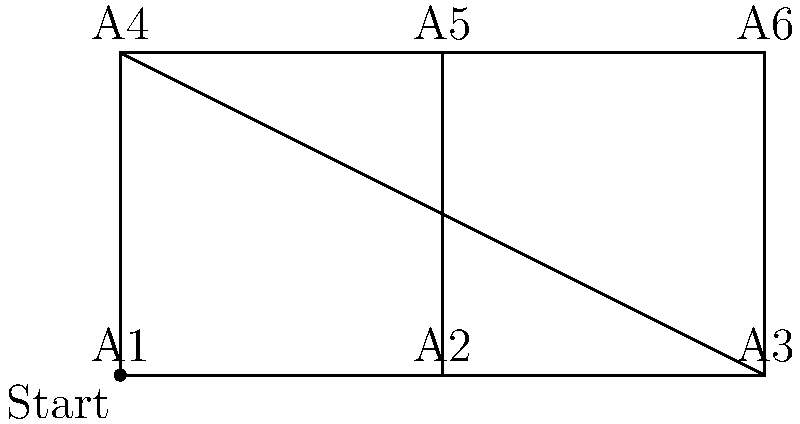As the store owner, you need to restock all aisles efficiently. The map shows 6 aisles (A1 to A6) connected by paths. Starting from A1, what's the shortest path to visit all aisles once and return to A1? To find the most efficient route, we need to consider all possible paths that visit each aisle once and return to the starting point. This is known as the Traveling Salesman Problem. For a small number of aisles like this, we can solve it by checking all possibilities:

1. There are 5! (120) possible routes, as we start and end at A1.
2. We can eliminate some routes that are clearly inefficient, such as those that cross the store multiple times.
3. The most efficient route should follow the store's layout, moving in a logical sequence.
4. Considering the layout, a good candidate for the shortest path is:
   A1 → A2 → A3 → A6 → A5 → A4 → A1

5. This path covers all aisles in a clockwise manner, following the store's layout without any backtracking.
6. The total distance of this path is 6 units (assuming each segment between adjacent aisles is 1 unit).
7. Any other path would require more movement or backtracking, resulting in a longer total distance.

Therefore, the most efficient route to restock all aisles is A1 → A2 → A3 → A6 → A5 → A4 → A1.
Answer: A1 → A2 → A3 → A6 → A5 → A4 → A1 